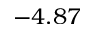<formula> <loc_0><loc_0><loc_500><loc_500>- 4 . 8 7</formula> 